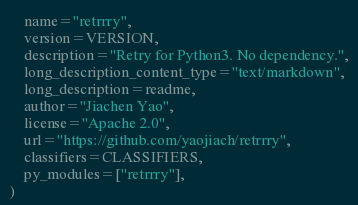Convert code to text. <code><loc_0><loc_0><loc_500><loc_500><_Python_>    name="retrrry",
    version=VERSION,
    description="Retry for Python3. No dependency.",
    long_description_content_type="text/markdown",
    long_description=readme,
    author="Jiachen Yao",
    license="Apache 2.0",
    url="https://github.com/yaojiach/retrrry",
    classifiers=CLASSIFIERS,
    py_modules=["retrrry"],
)
</code> 